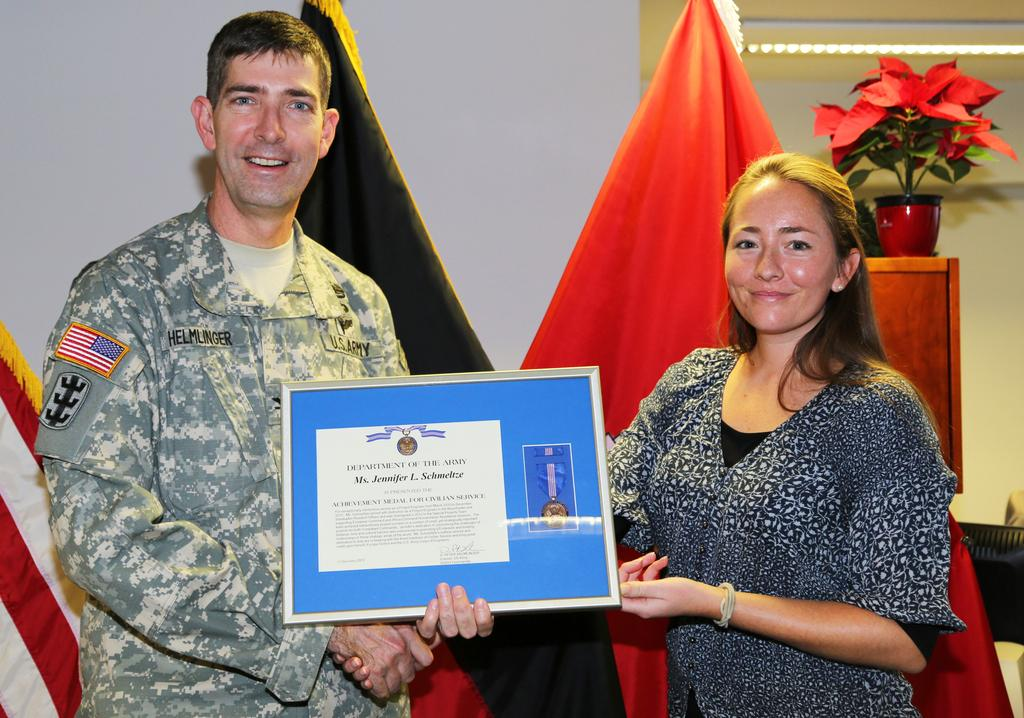How many people are in the image? There are two persons in the image. What are the two persons doing in the image? The two persons are holding an object. Can you describe the plant in the image? There is a plant in a flower pot. What is the background of the image? There is a wall in the image. What else can be seen in the image? There is a cloth in the image. How many stars can be seen in the image? There are no stars visible in the image. Can you describe the eye color of the persons in the image? The image does not show the eye color of the persons; it only shows them holding an object. 